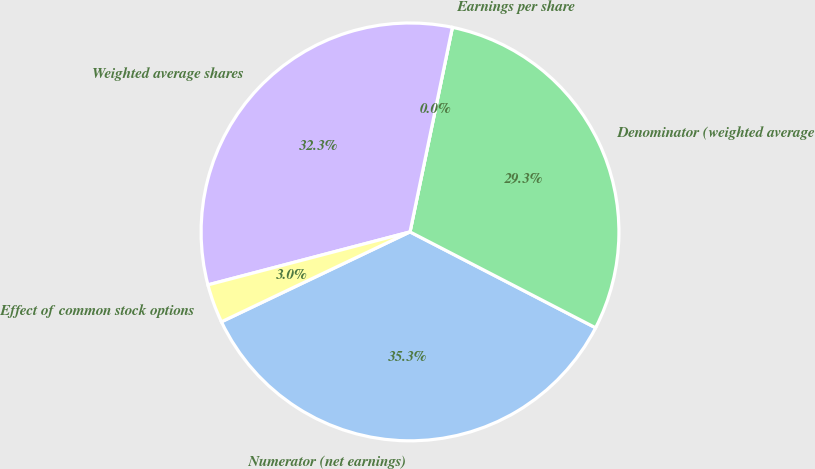Convert chart to OTSL. <chart><loc_0><loc_0><loc_500><loc_500><pie_chart><fcel>Numerator (net earnings)<fcel>Denominator (weighted average<fcel>Earnings per share<fcel>Weighted average shares<fcel>Effect of common stock options<nl><fcel>35.33%<fcel>29.34%<fcel>0.0%<fcel>32.33%<fcel>3.0%<nl></chart> 